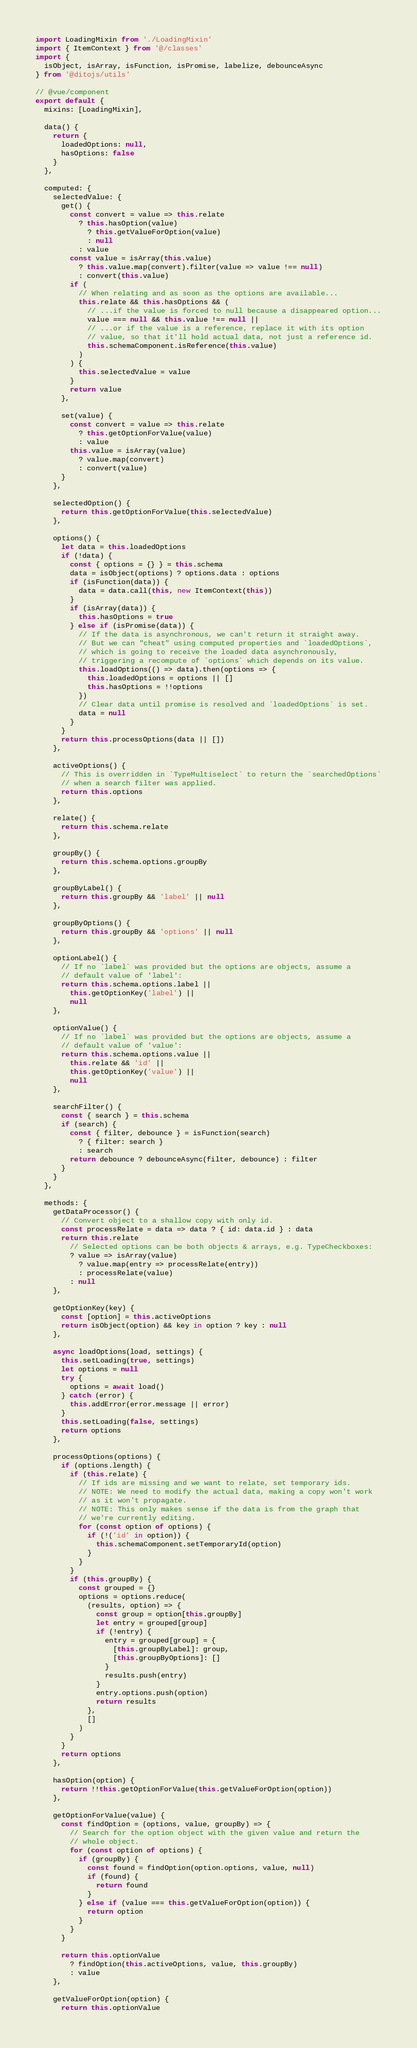<code> <loc_0><loc_0><loc_500><loc_500><_JavaScript_>import LoadingMixin from './LoadingMixin'
import { ItemContext } from '@/classes'
import {
  isObject, isArray, isFunction, isPromise, labelize, debounceAsync
} from '@ditojs/utils'

// @vue/component
export default {
  mixins: [LoadingMixin],

  data() {
    return {
      loadedOptions: null,
      hasOptions: false
    }
  },

  computed: {
    selectedValue: {
      get() {
        const convert = value => this.relate
          ? this.hasOption(value)
            ? this.getValueForOption(value)
            : null
          : value
        const value = isArray(this.value)
          ? this.value.map(convert).filter(value => value !== null)
          : convert(this.value)
        if (
          // When relating and as soon as the options are available...
          this.relate && this.hasOptions && (
            // ...if the value is forced to null because a disappeared option...
            value === null && this.value !== null ||
            // ...or if the value is a reference, replace it with its option
            // value, so that it'll hold actual data, not just a reference id.
            this.schemaComponent.isReference(this.value)
          )
        ) {
          this.selectedValue = value
        }
        return value
      },

      set(value) {
        const convert = value => this.relate
          ? this.getOptionForValue(value)
          : value
        this.value = isArray(value)
          ? value.map(convert)
          : convert(value)
      }
    },

    selectedOption() {
      return this.getOptionForValue(this.selectedValue)
    },

    options() {
      let data = this.loadedOptions
      if (!data) {
        const { options = {} } = this.schema
        data = isObject(options) ? options.data : options
        if (isFunction(data)) {
          data = data.call(this, new ItemContext(this))
        }
        if (isArray(data)) {
          this.hasOptions = true
        } else if (isPromise(data)) {
          // If the data is asynchronous, we can't return it straight away.
          // But we can "cheat" using computed properties and `loadedOptions`,
          // which is going to receive the loaded data asynchronously,
          // triggering a recompute of `options` which depends on its value.
          this.loadOptions(() => data).then(options => {
            this.loadedOptions = options || []
            this.hasOptions = !!options
          })
          // Clear data until promise is resolved and `loadedOptions` is set.
          data = null
        }
      }
      return this.processOptions(data || [])
    },

    activeOptions() {
      // This is overridden in `TypeMultiselect` to return the `searchedOptions`
      // when a search filter was applied.
      return this.options
    },

    relate() {
      return this.schema.relate
    },

    groupBy() {
      return this.schema.options.groupBy
    },

    groupByLabel() {
      return this.groupBy && 'label' || null
    },

    groupByOptions() {
      return this.groupBy && 'options' || null
    },

    optionLabel() {
      // If no `label` was provided but the options are objects, assume a
      // default value of 'label':
      return this.schema.options.label ||
        this.getOptionKey('label') ||
        null
    },

    optionValue() {
      // If no `label` was provided but the options are objects, assume a
      // default value of 'value':
      return this.schema.options.value ||
        this.relate && 'id' ||
        this.getOptionKey('value') ||
        null
    },

    searchFilter() {
      const { search } = this.schema
      if (search) {
        const { filter, debounce } = isFunction(search)
          ? { filter: search }
          : search
        return debounce ? debounceAsync(filter, debounce) : filter
      }
    }
  },

  methods: {
    getDataProcessor() {
      // Convert object to a shallow copy with only id.
      const processRelate = data => data ? { id: data.id } : data
      return this.relate
        // Selected options can be both objects & arrays, e.g. TypeCheckboxes:
        ? value => isArray(value)
          ? value.map(entry => processRelate(entry))
          : processRelate(value)
        : null
    },

    getOptionKey(key) {
      const [option] = this.activeOptions
      return isObject(option) && key in option ? key : null
    },

    async loadOptions(load, settings) {
      this.setLoading(true, settings)
      let options = null
      try {
        options = await load()
      } catch (error) {
        this.addError(error.message || error)
      }
      this.setLoading(false, settings)
      return options
    },

    processOptions(options) {
      if (options.length) {
        if (this.relate) {
          // If ids are missing and we want to relate, set temporary ids.
          // NOTE: We need to modify the actual data, making a copy won't work
          // as it won't propagate.
          // NOTE: This only makes sense if the data is from the graph that
          // we're currently editing.
          for (const option of options) {
            if (!('id' in option)) {
              this.schemaComponent.setTemporaryId(option)
            }
          }
        }
        if (this.groupBy) {
          const grouped = {}
          options = options.reduce(
            (results, option) => {
              const group = option[this.groupBy]
              let entry = grouped[group]
              if (!entry) {
                entry = grouped[group] = {
                  [this.groupByLabel]: group,
                  [this.groupByOptions]: []
                }
                results.push(entry)
              }
              entry.options.push(option)
              return results
            },
            []
          )
        }
      }
      return options
    },

    hasOption(option) {
      return !!this.getOptionForValue(this.getValueForOption(option))
    },

    getOptionForValue(value) {
      const findOption = (options, value, groupBy) => {
        // Search for the option object with the given value and return the
        // whole object.
        for (const option of options) {
          if (groupBy) {
            const found = findOption(option.options, value, null)
            if (found) {
              return found
            }
          } else if (value === this.getValueForOption(option)) {
            return option
          }
        }
      }

      return this.optionValue
        ? findOption(this.activeOptions, value, this.groupBy)
        : value
    },

    getValueForOption(option) {
      return this.optionValue</code> 